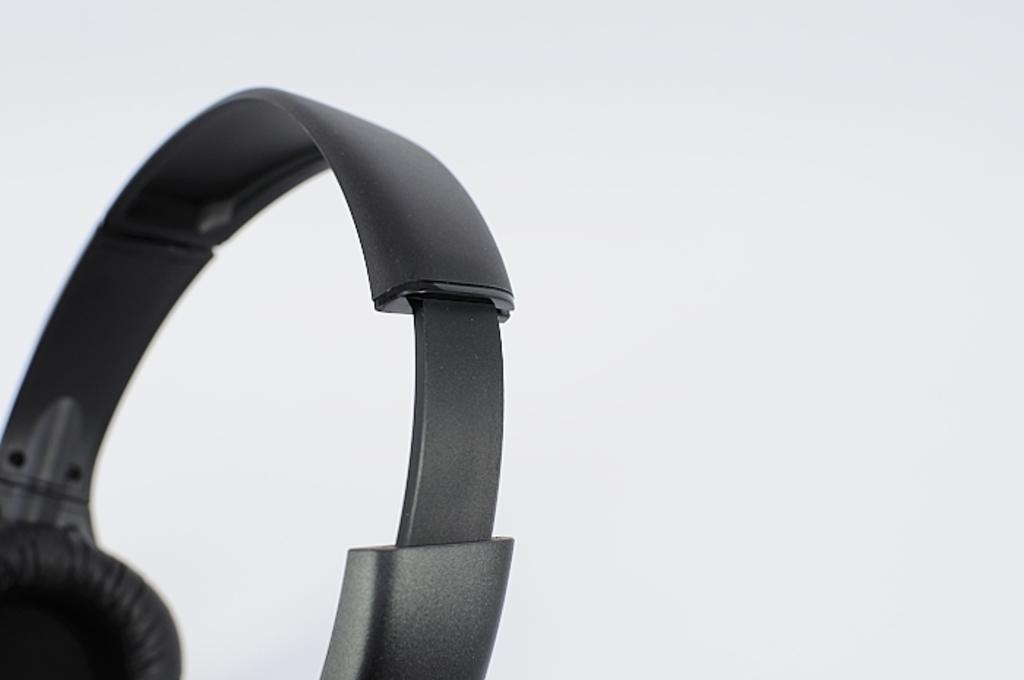Could you give a brief overview of what you see in this image? In this image we can see a headphone. The background of the image is white in color. 